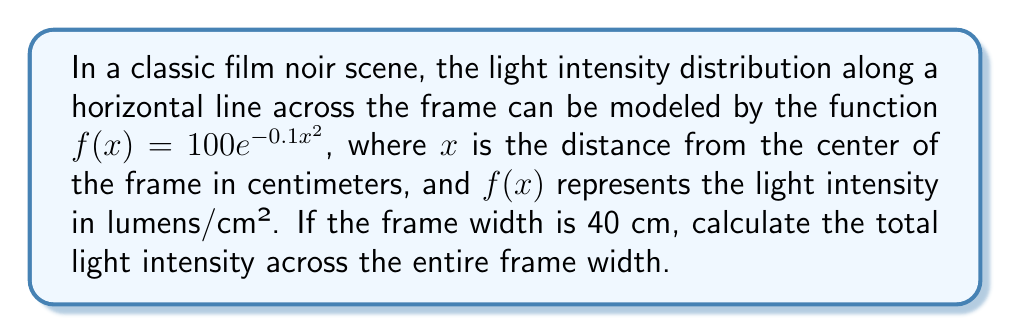Provide a solution to this math problem. To solve this problem, we need to integrate the light intensity function over the width of the frame. Let's break it down step-by-step:

1. The frame width is 40 cm, so we need to integrate from -20 cm to 20 cm (assuming the center is at x = 0).

2. Set up the definite integral:
   $$\int_{-20}^{20} 100e^{-0.1x^2} dx$$

3. This integral doesn't have an elementary antiderivative, so we need to recognize it as a form of the Gaussian integral.

4. The standard form of the Gaussian integral is:
   $$\int_{-\infty}^{\infty} e^{-ax^2} dx = \sqrt{\frac{\pi}{a}}$$

5. Our integral is similar, but with finite limits and a constant factor. We can rewrite it as:
   $$100 \int_{-20}^{20} e^{-0.1x^2} dx$$

6. Comparing to the standard form, we have $a = 0.1$

7. We can approximate our integral using the error function (erf):
   $$100 \cdot \sqrt{\frac{\pi}{0.1}} \cdot \frac{\text{erf}(20\sqrt{0.1})}{\sqrt{\pi}}$$

8. Simplify:
   $$100 \cdot \sqrt{10\pi} \cdot \frac{\text{erf}(20\sqrt{0.1})}{\sqrt{\pi}}$$

9. Calculate:
   $$100 \cdot \sqrt{10} \cdot \text{erf}(6.32) \approx 316.2$$

The error function at 6.32 is very close to 1, so our final result is approximately 316.2 lumens.
Answer: $316.2$ lumens 